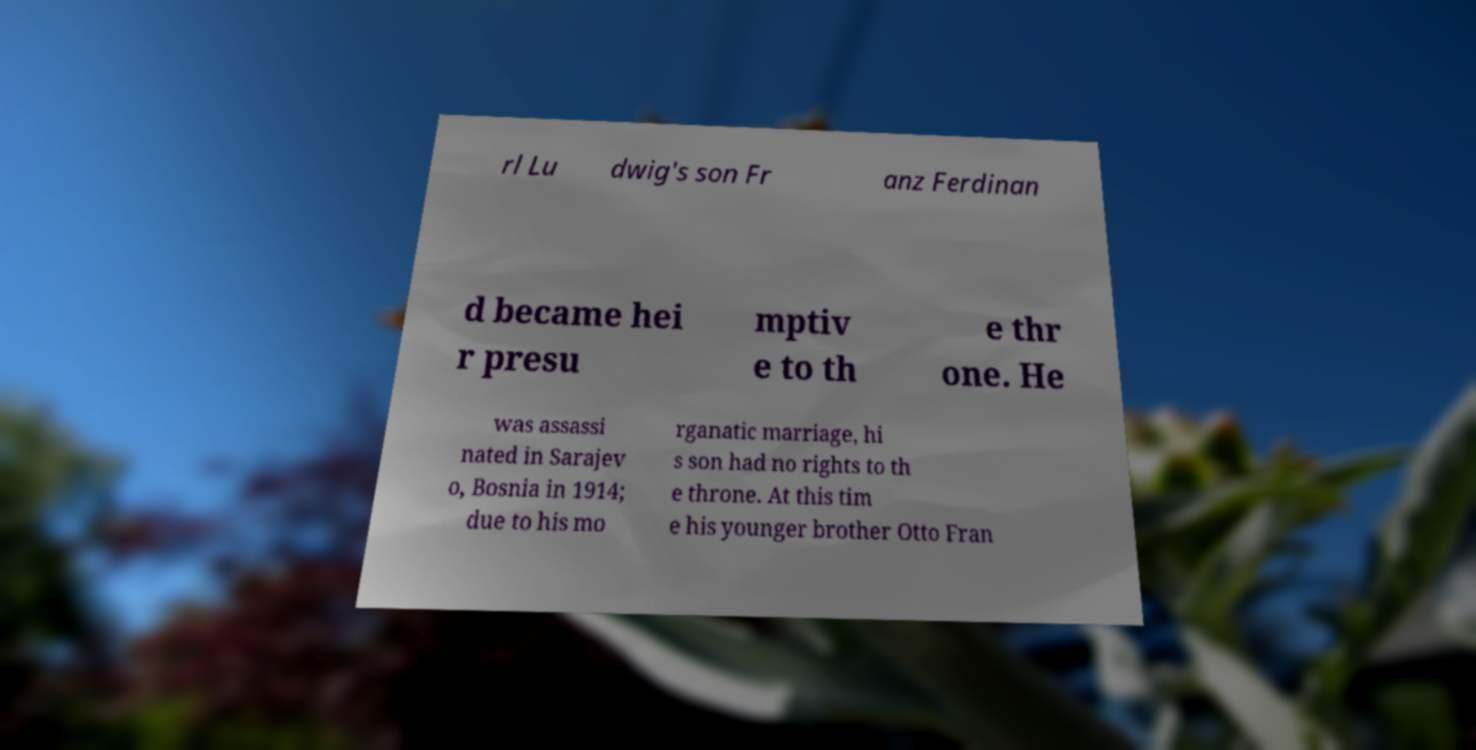I need the written content from this picture converted into text. Can you do that? rl Lu dwig's son Fr anz Ferdinan d became hei r presu mptiv e to th e thr one. He was assassi nated in Sarajev o, Bosnia in 1914; due to his mo rganatic marriage, hi s son had no rights to th e throne. At this tim e his younger brother Otto Fran 